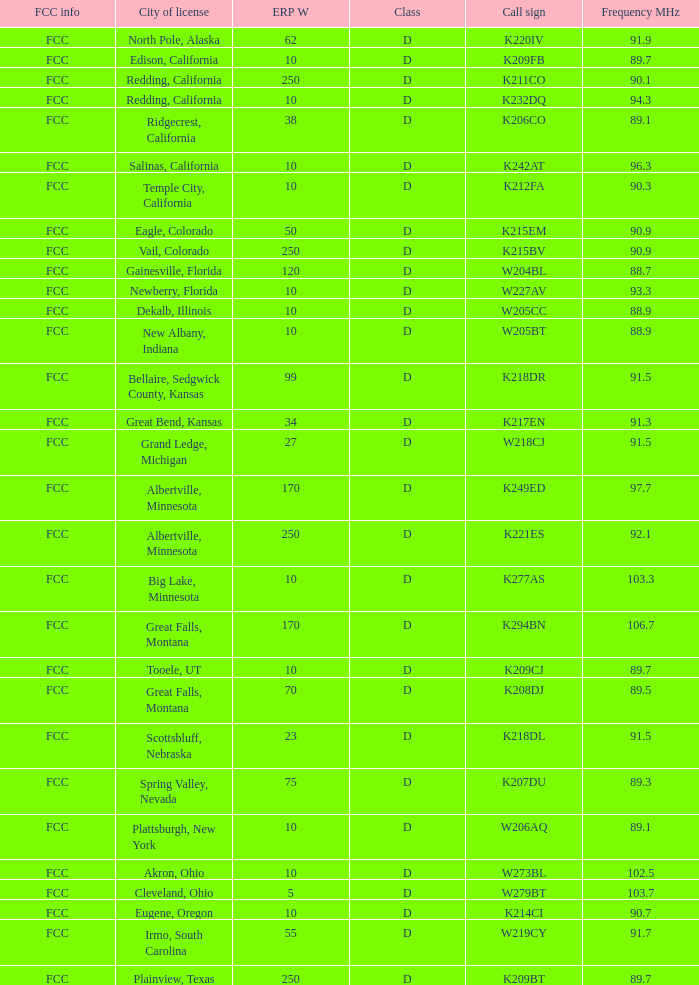In which class can a translator with a w273bl call sign and 10 erp w be found? D. 